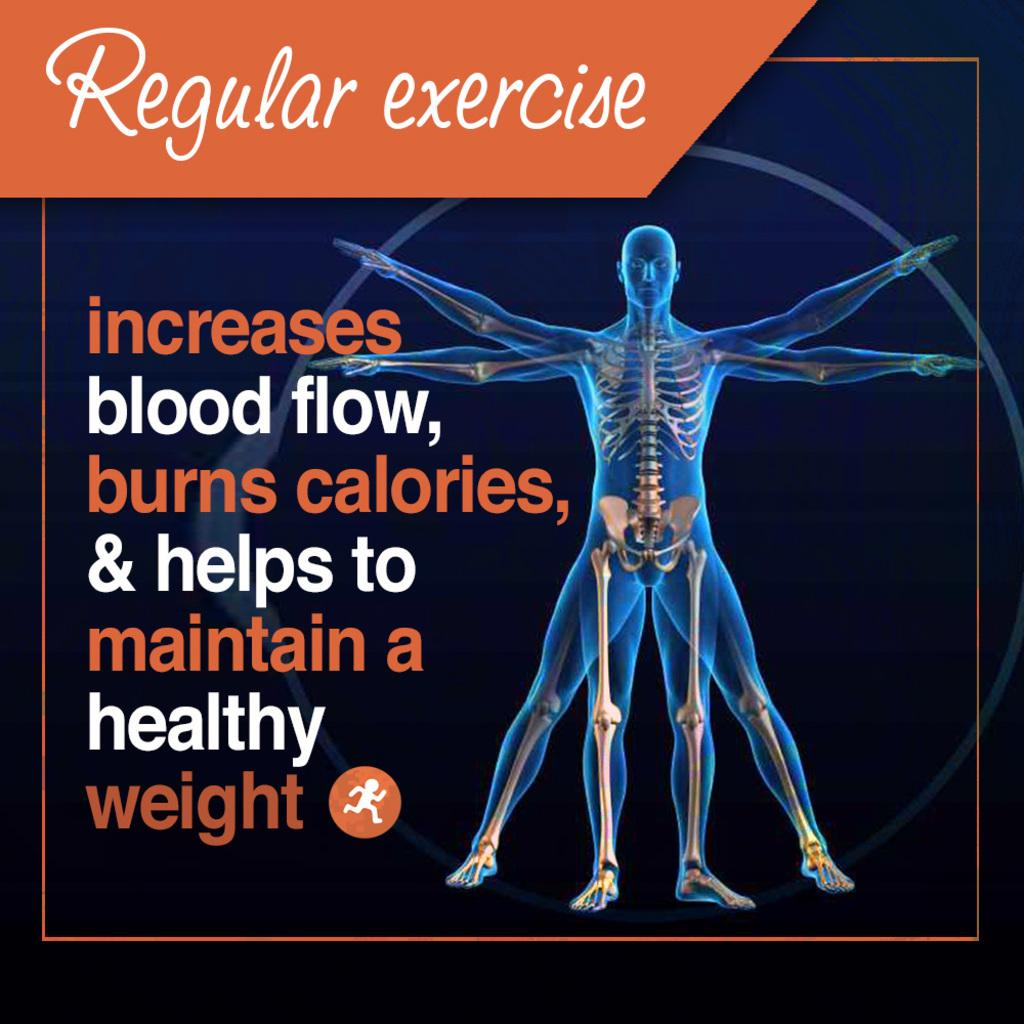<image>
Present a compact description of the photo's key features. an infographic on how exercise can increase blood flow burn calories and maintain a healthy weight. 